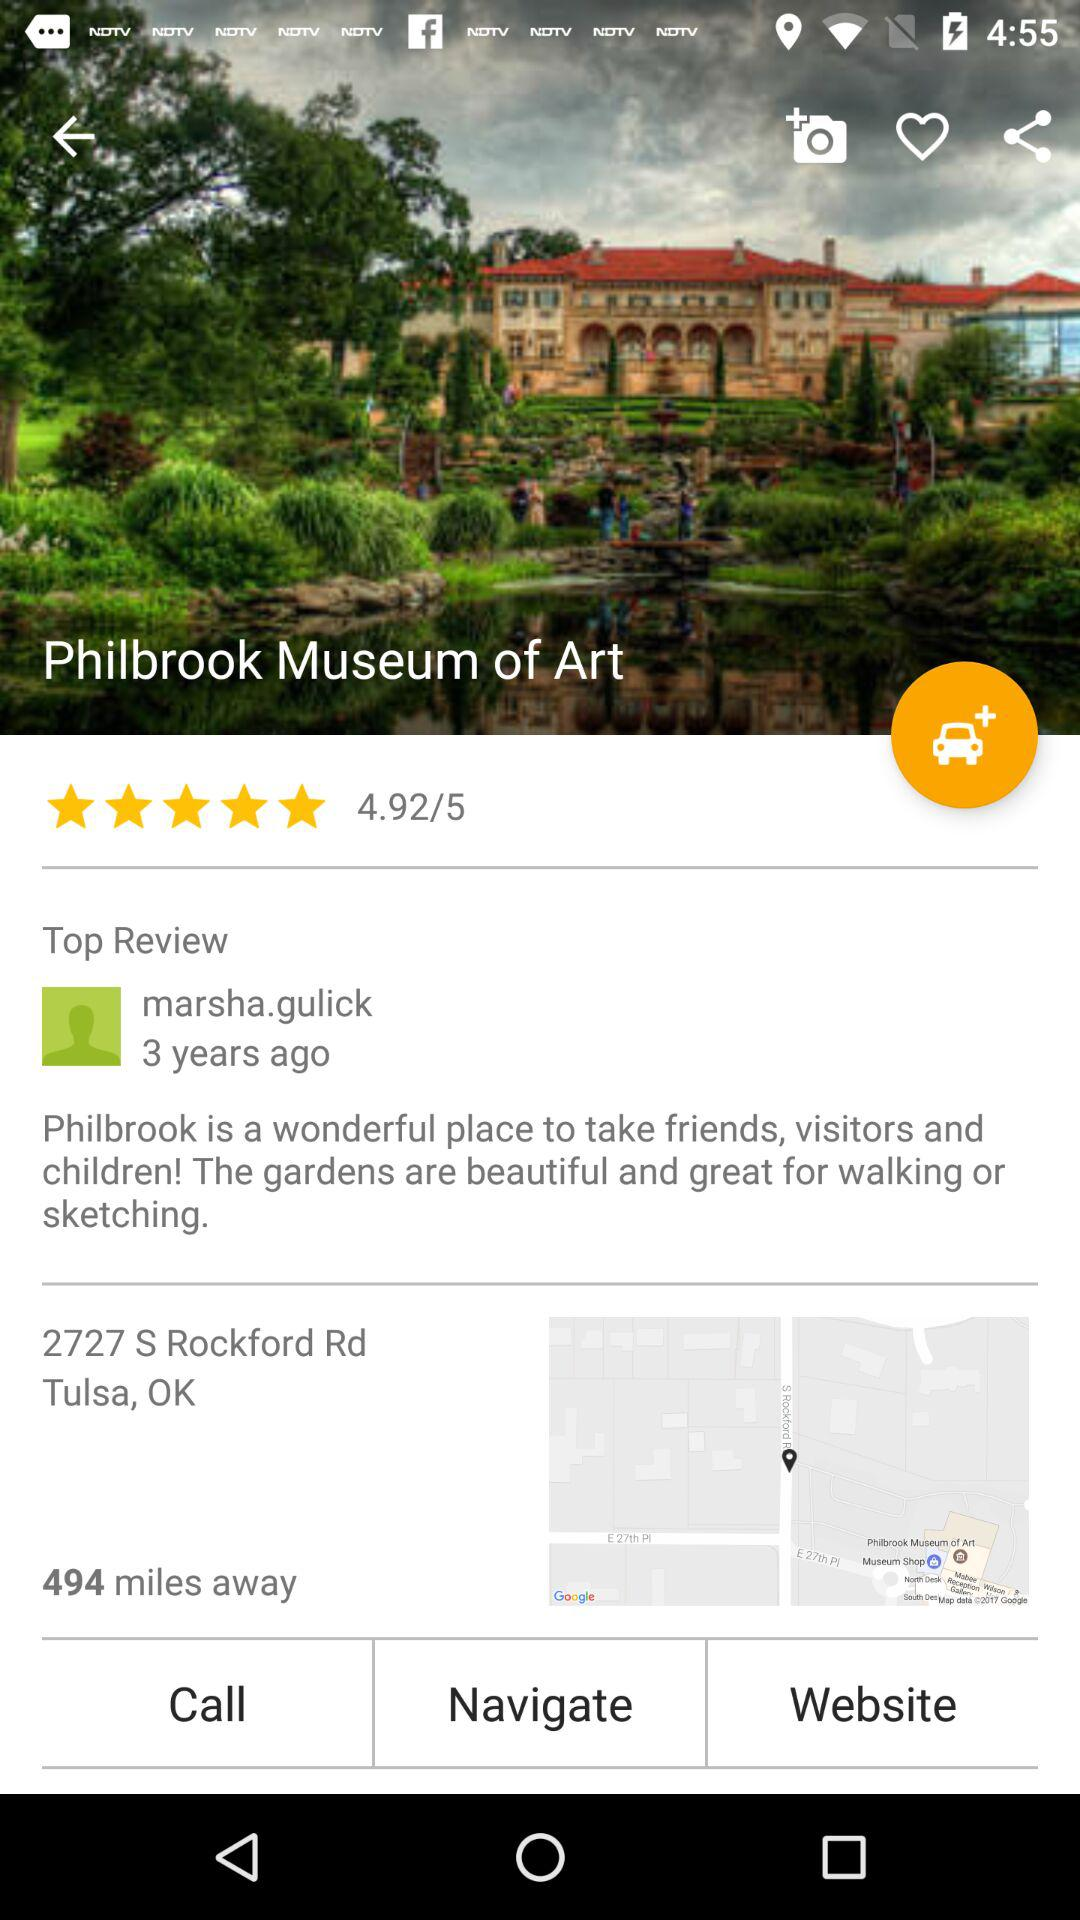How much is the distance? The distance is 494 miles. 